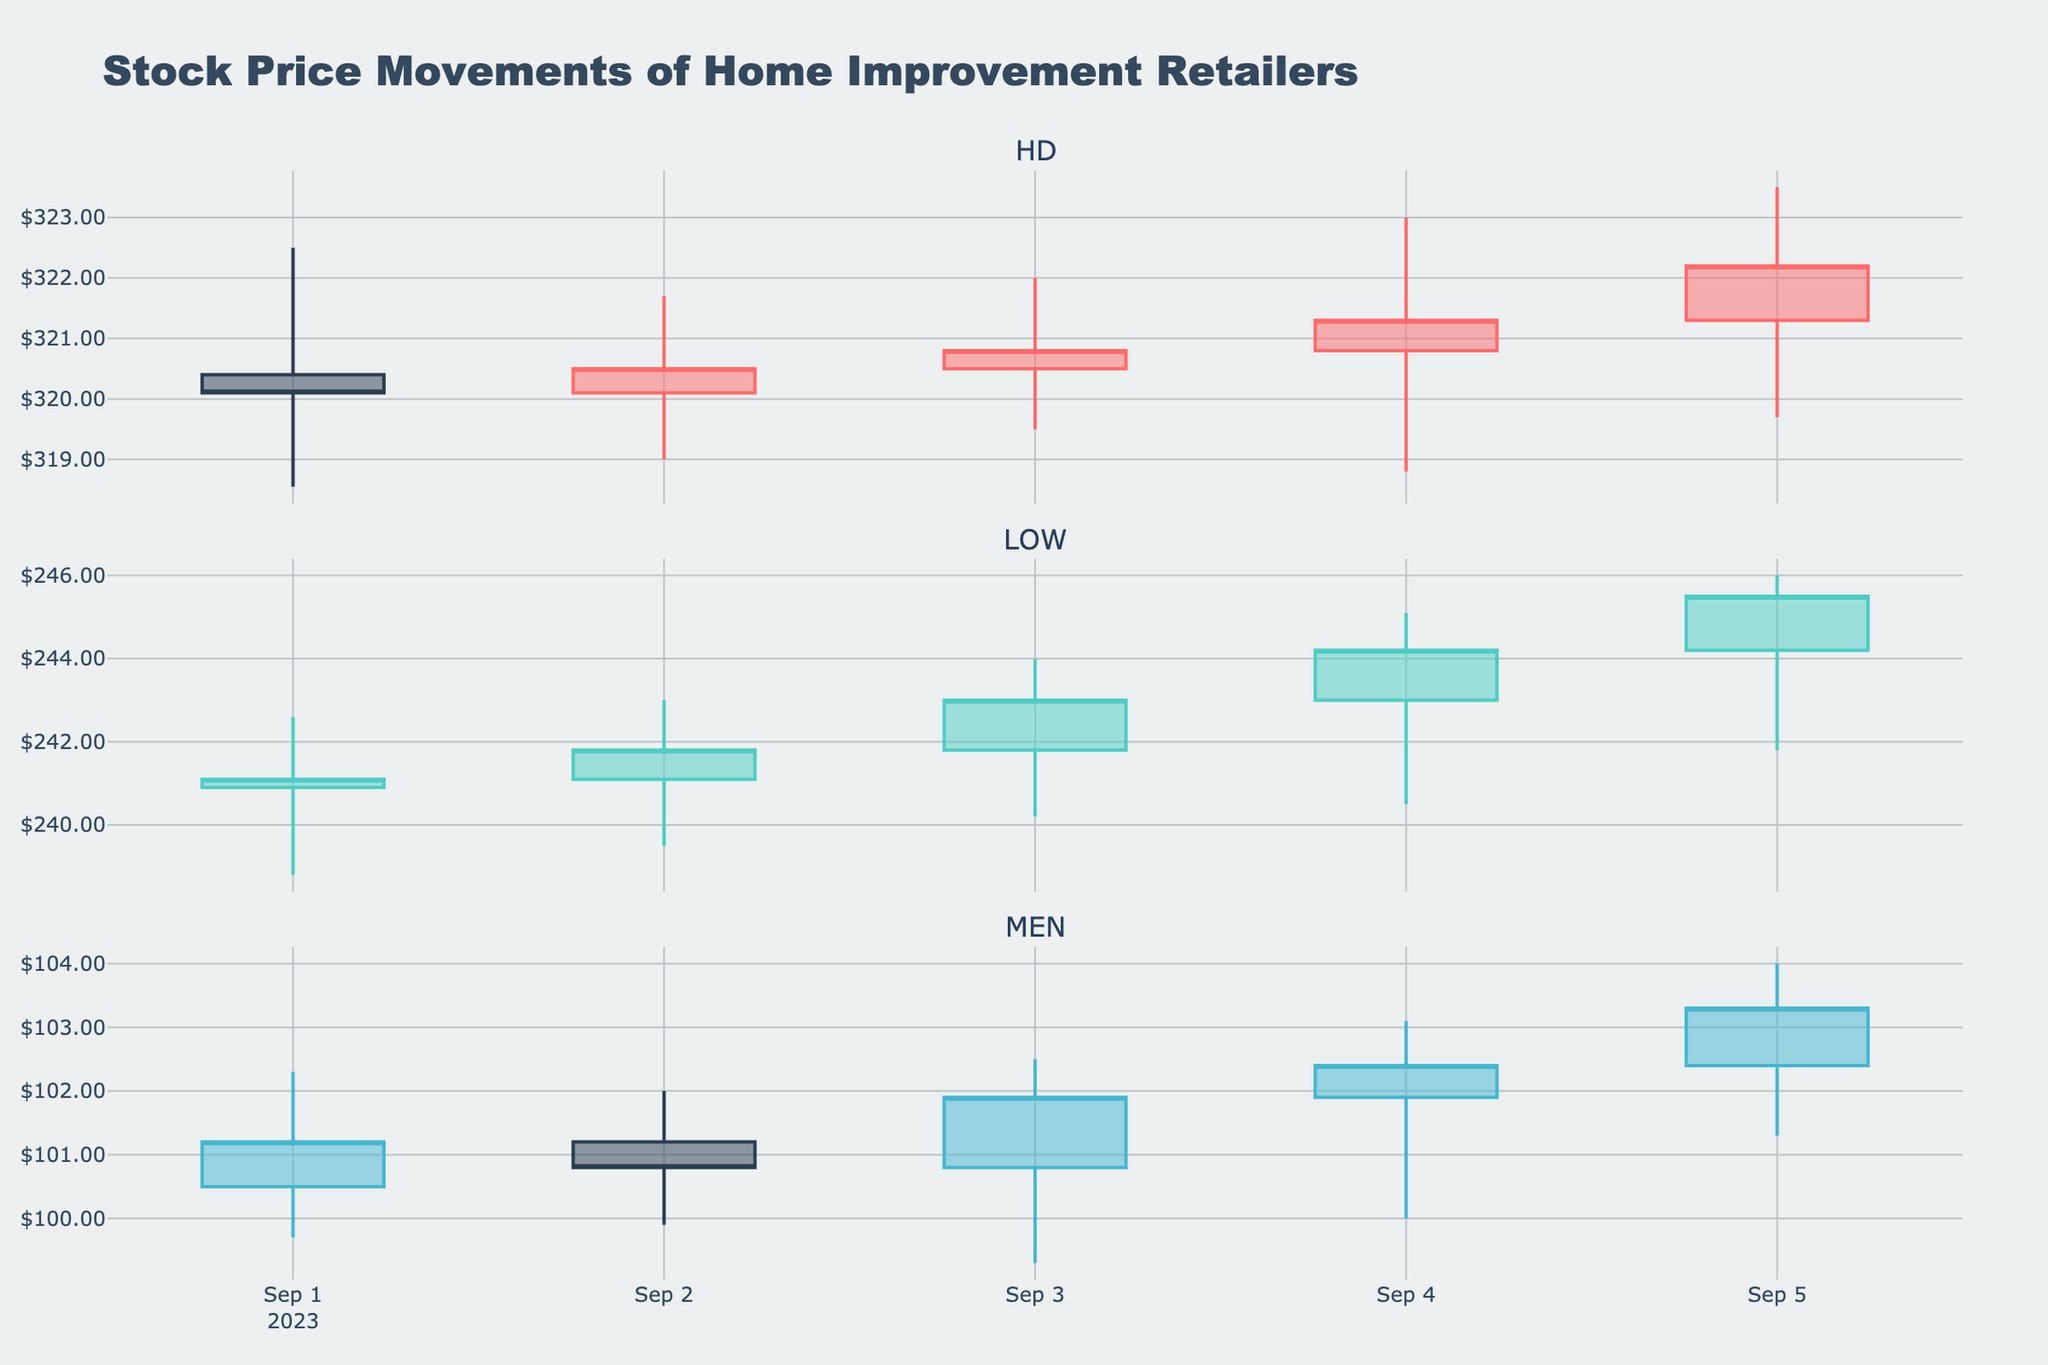What is the title of the figure? The title is located at the top center of the figure, often in a larger and bold font to draw attention.
Answer: Stock Price Movements of Home Improvement Retailers How many companies' stock prices are represented in the figure? There are separate subplot titles for each company, there being three titles (HD, LOW, and MEN) indicating three companies.
Answer: 3 Which company has the highest closing price on September 5, 2023? Look at the closing prices on September 5th for each company. HD closes at 322.20, LOW closes at 245.50, and MEN closes at 103.30. HD has the highest closing price among the three.
Answer: HD What is the overall trend for MEN's stock price from September 1 to September 5, 2023? By observing the candlestick colors and general trend, MEN's stock price starts at 101.20 and increases to 103.30 by September 5th.
Answer: Upward Which company showed the highest volatility in stock prices on September 4, 2023? Volatility can be assessed by the size of the candlestick (the range between the high and low). HD ranges from 323.00 to 318.80, LOW ranges from 245.10 to 240.50, and MEN ranges from 103.10 to 100.00. HD has the highest range.
Answer: HD How does the trading volume for LOW on September 3, 2023, compare to its trading volume on September 4, 2023? Check the trading volume for LOW on both dates; September 3 has a volume of 3,400,000, while September 4 has a volume of 3,700,000. September 4 is higher.
Answer: Trading volume is higher on September 4 What is the median closing price for MEN from September 1 to September 5, 2023? Arrange the closing prices in order (99.70, 100.80, 101.20, 101.90, 103.30). The median value, the third value in the sorted list, is 101.90.
Answer: 101.90 Which company experienced a continuous increase in stock prices for all days from September 1 to September 5, 2023? Check if there is any company where each day's closing price is higher than the previous day's. LOW starts at 241.10 and continuously increases to 245.50 by September 5th.
Answer: LOW 